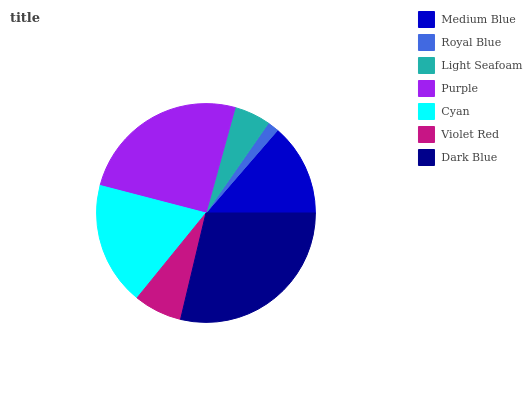Is Royal Blue the minimum?
Answer yes or no. Yes. Is Dark Blue the maximum?
Answer yes or no. Yes. Is Light Seafoam the minimum?
Answer yes or no. No. Is Light Seafoam the maximum?
Answer yes or no. No. Is Light Seafoam greater than Royal Blue?
Answer yes or no. Yes. Is Royal Blue less than Light Seafoam?
Answer yes or no. Yes. Is Royal Blue greater than Light Seafoam?
Answer yes or no. No. Is Light Seafoam less than Royal Blue?
Answer yes or no. No. Is Medium Blue the high median?
Answer yes or no. Yes. Is Medium Blue the low median?
Answer yes or no. Yes. Is Violet Red the high median?
Answer yes or no. No. Is Dark Blue the low median?
Answer yes or no. No. 